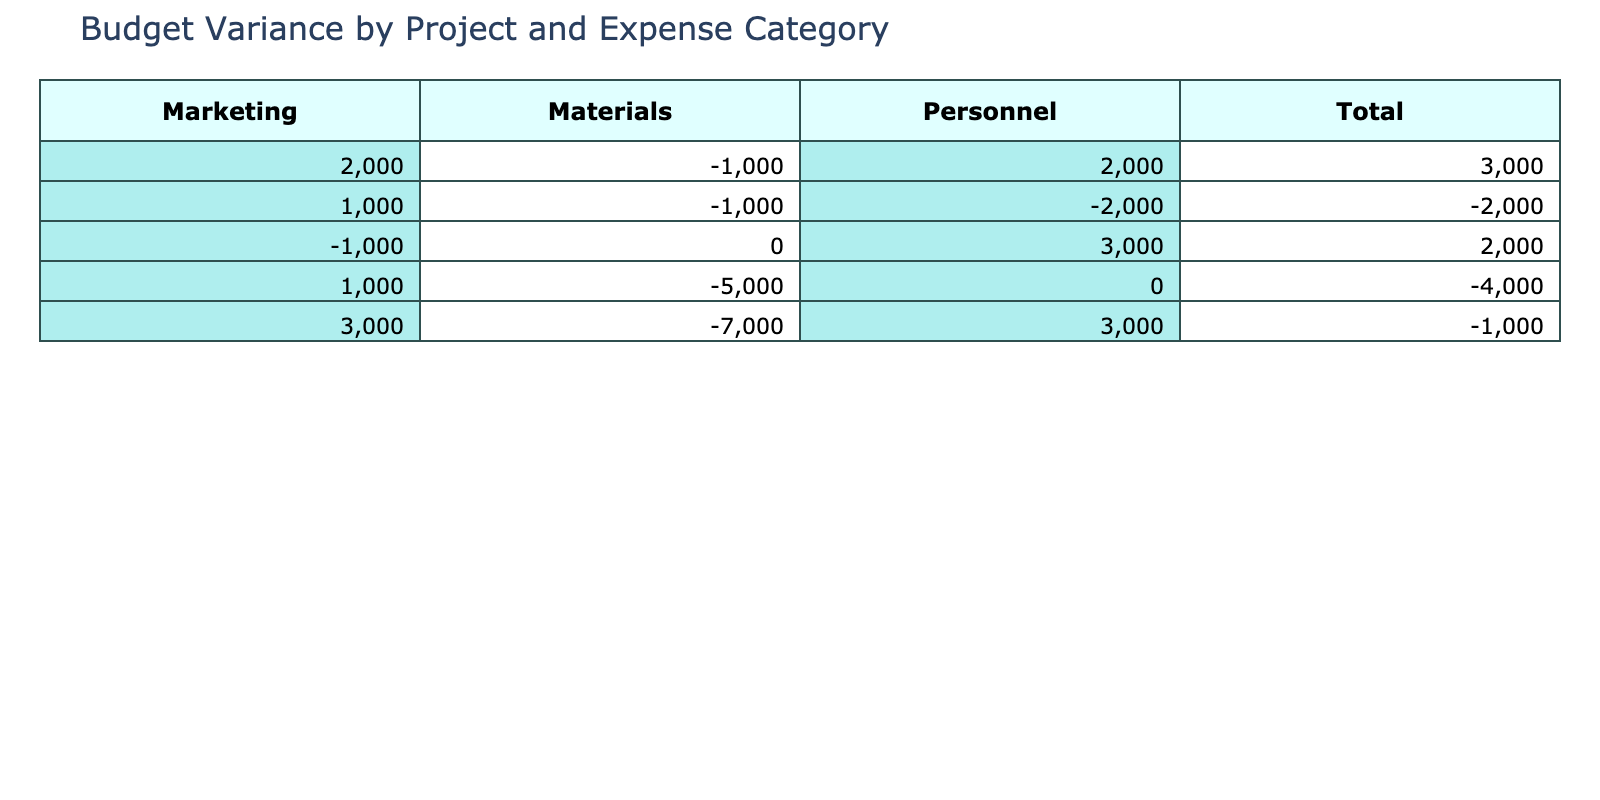What is the Budget Variance for Project Alpha in Personnel? The table shows that for Project Alpha under the Personnel category, the Planned Budget is 50000 and the Actual Expenditure is 48000, resulting in a Budget Variance of 2000.
Answer: 2000 What is the total Budget Variance for Project Beta? To calculate the total Budget Variance for Project Beta, we add up the Budget Variance values for each expense category: -2000 (Personnel) + -1000 (Materials) + 1000 (Marketing) = -2000.
Answer: -2000 Is the Budget Variance for Project Delta under Marketing positive? The table indicates that the Budget Variance for Project Delta under the Marketing category is -1000, which means it is not positive.
Answer: No Which project has the highest total Budget Variance? We need to compare the total Budget Variance of each project: Project Alpha (2000 + -1000 + 2000 = 3000), Project Beta (-2000 + -1000 + 1000 = -2000), Project Gamma (0 + -5000 + 1000 = -4000), and Project Delta (3000 + 0 + -1000 = 2000). Project Alpha has the highest total Budget Variance of 3000.
Answer: Project Alpha What is the average Budget Variance for Materials across all projects? We need to add the Budget Variance for Materials: -1000 (Project Alpha) + -1000 (Project Beta) + -5000 (Project Gamma) + 0 (Project Delta) = -7000. There are four entries, so we divide -7000 by 4, which gives us an average of -1750.
Answer: -1750 Is there any expense category where the actual expenditure exceeded the planned budget for all projects? We need to check if any category shows a Budget Variance less than zero across all projects: Personnel has both positive and negative variances, Materials has negative variances for Project Alpha, Beta, and Gamma, while Marketing has only one negative entry for Project Delta. Since no category is consistently negative for all projects, the answer is no.
Answer: No What is the combined Budget Variance for Personnel across all projects? We need to sum the Budget Variance for Personnel: 2000 (Project Alpha) + -2000 (Project Beta) + 0 (Project Gamma) + 3000 (Project Delta) = 3000.
Answer: 3000 Which project had the least favorable Budget Variance overall? We compare total variances: Project Alpha (3000), Project Beta (-2000), Project Gamma (-4000), and Project Delta (2000). Project Gamma has the least favorable Budget Variance at -4000.
Answer: Project Gamma 